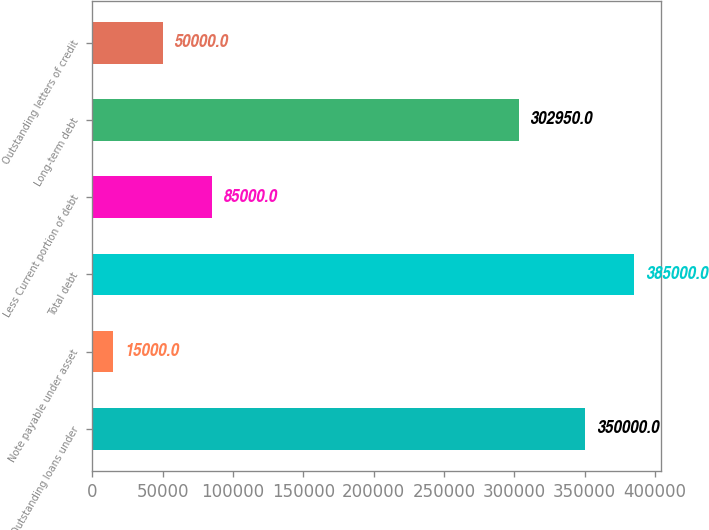Convert chart. <chart><loc_0><loc_0><loc_500><loc_500><bar_chart><fcel>Outstanding loans under<fcel>Note payable under asset<fcel>Total debt<fcel>Less Current portion of debt<fcel>Long-term debt<fcel>Outstanding letters of credit<nl><fcel>350000<fcel>15000<fcel>385000<fcel>85000<fcel>302950<fcel>50000<nl></chart> 